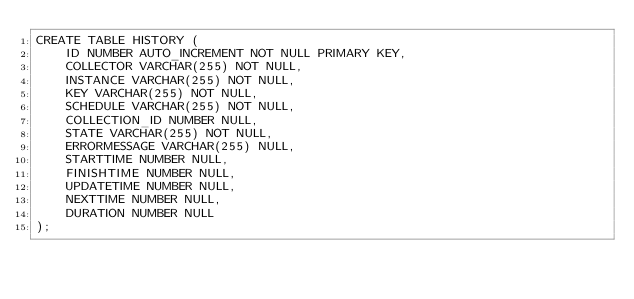Convert code to text. <code><loc_0><loc_0><loc_500><loc_500><_SQL_>CREATE TABLE HISTORY (
    ID NUMBER AUTO_INCREMENT NOT NULL PRIMARY KEY,
    COLLECTOR VARCHAR(255) NOT NULL,
    INSTANCE VARCHAR(255) NOT NULL,
    KEY VARCHAR(255) NOT NULL,    
    SCHEDULE VARCHAR(255) NOT NULL,    
    COLLECTION_ID NUMBER NULL,
    STATE VARCHAR(255) NOT NULL,
    ERRORMESSAGE VARCHAR(255) NULL,
    STARTTIME NUMBER NULL,
    FINISHTIME NUMBER NULL,
    UPDATETIME NUMBER NULL,
    NEXTTIME NUMBER NULL,
    DURATION NUMBER NULL
);</code> 